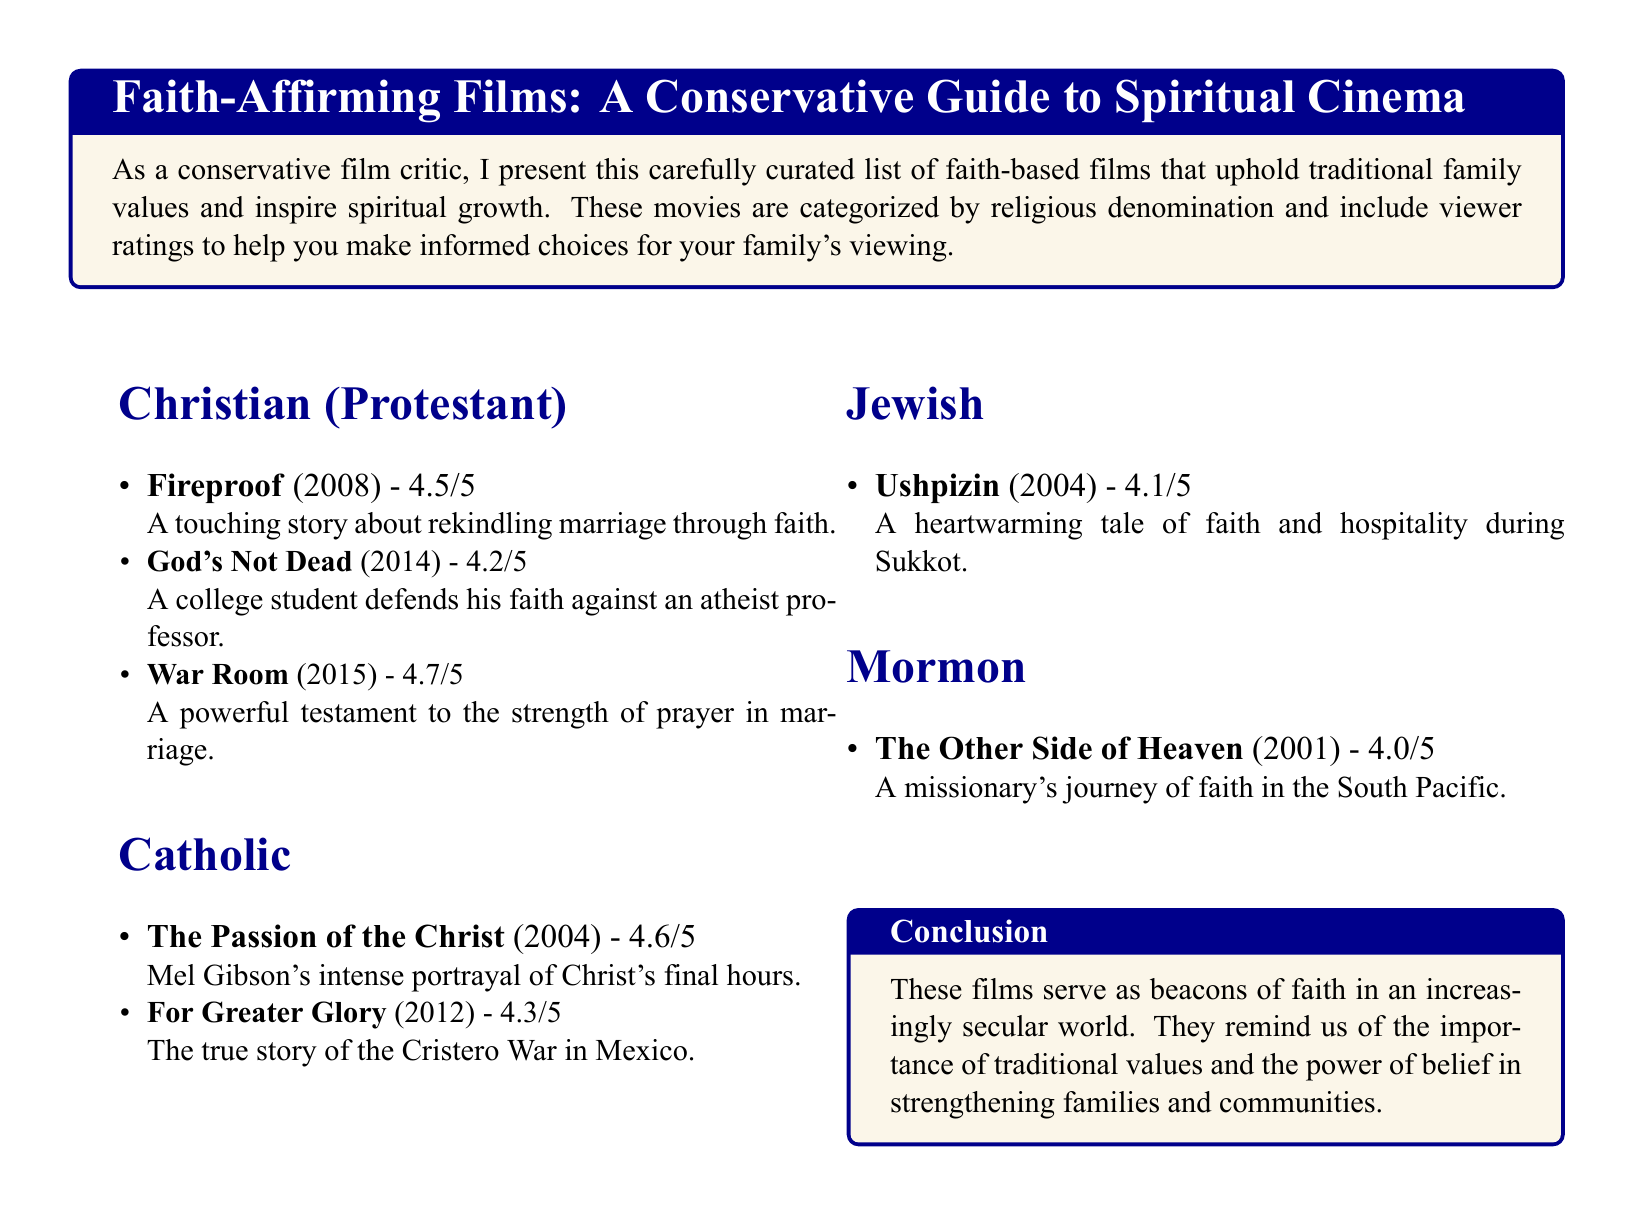What is the viewer rating of "Fireproof"? The viewer rating is specified in the document as 4.5 out of 5.
Answer: 4.5/5 What year was "God's Not Dead" released? The year of release for "God's Not Dead" is mentioned in the title of the movie listing.
Answer: 2014 Which film depicts the final hours of Christ? The film's title is given in the Catholic section as the one that depicts Christ's final hours.
Answer: The Passion of the Christ How many films are listed under the Jewish category? The number of films is found by counting the entries in the Jewish section.
Answer: 1 What is the main theme of "War Room"? The main theme is derived from the description provided in the document about the film.
Answer: Strength of prayer in marriage What religious denomination is "The Other Side of Heaven" associated with? The denomination is mentioned in the context of the movie title in the Mormon category.
Answer: Mormon What is the lowest viewer rating among the listed films? The lowest rating can be identified when comparing the ratings shown for each film.
Answer: 4.0/5 Which film showcases a true story about a war in Mexico? The title is provided in the Catholic section and includes key information about the film's content.
Answer: For Greater Glory 